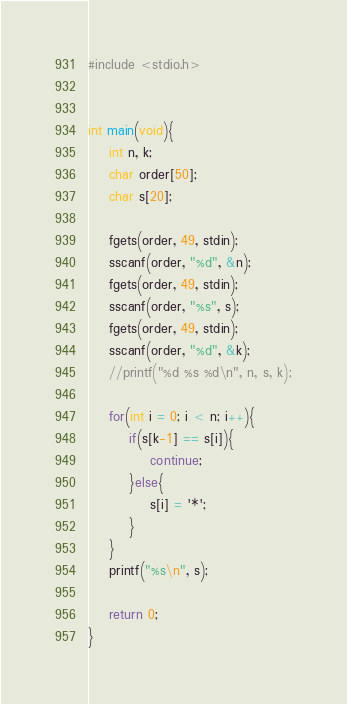<code> <loc_0><loc_0><loc_500><loc_500><_C++_>#include <stdio.h>


int main(void){
    int n, k;
    char order[50];
    char s[20];
    
    fgets(order, 49, stdin);
    sscanf(order, "%d", &n);
    fgets(order, 49, stdin);
    sscanf(order, "%s", s);
    fgets(order, 49, stdin);
    sscanf(order, "%d", &k);
    //printf("%d %s %d\n", n, s, k);
    
    for(int i = 0; i < n; i++){
        if(s[k-1] == s[i]){
            continue;
        }else{
            s[i] = '*';
        }
    }
    printf("%s\n", s);
    
    return 0;
}</code> 